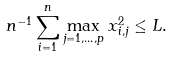Convert formula to latex. <formula><loc_0><loc_0><loc_500><loc_500>n ^ { - 1 } \sum _ { i = 1 } ^ { n } \max _ { j = 1 , \dots , p } x _ { i , j } ^ { 2 } \leq L .</formula> 